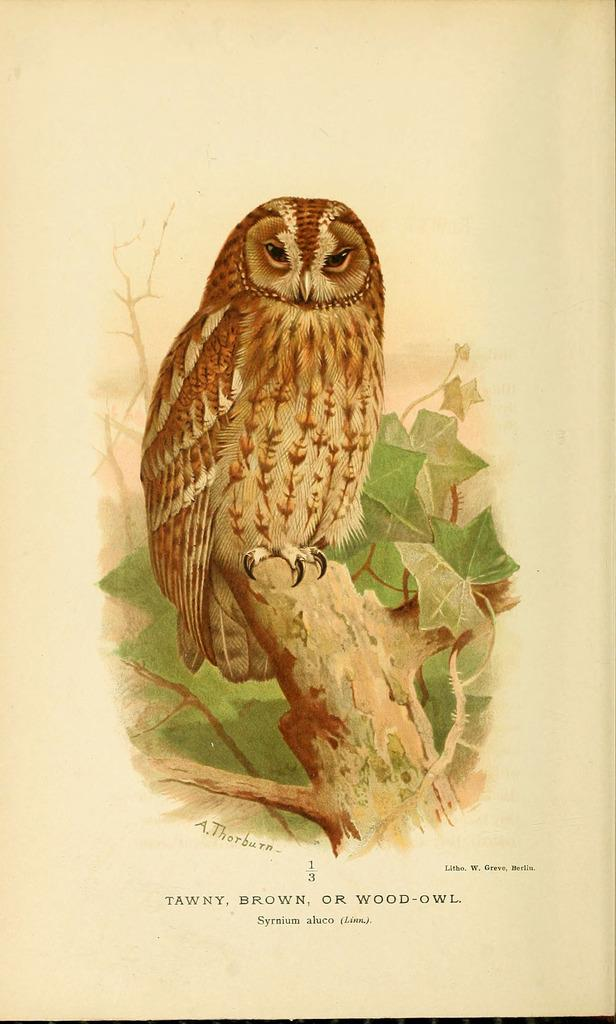What is depicted in the painting in the image? There is a painting of an owl in the image. Where is the owl located in the painting? The owl is standing on a tree in the painting. What else can be seen in the image besides the painting? There is text on a paper in the image. Can you tell me how many stores are visible in the image? There are no stores present in the image; it features a painting of an owl and text on a paper. What type of seashore can be seen in the image? There is no seashore depicted in the image; it contains a painting of an owl and text on a paper. 